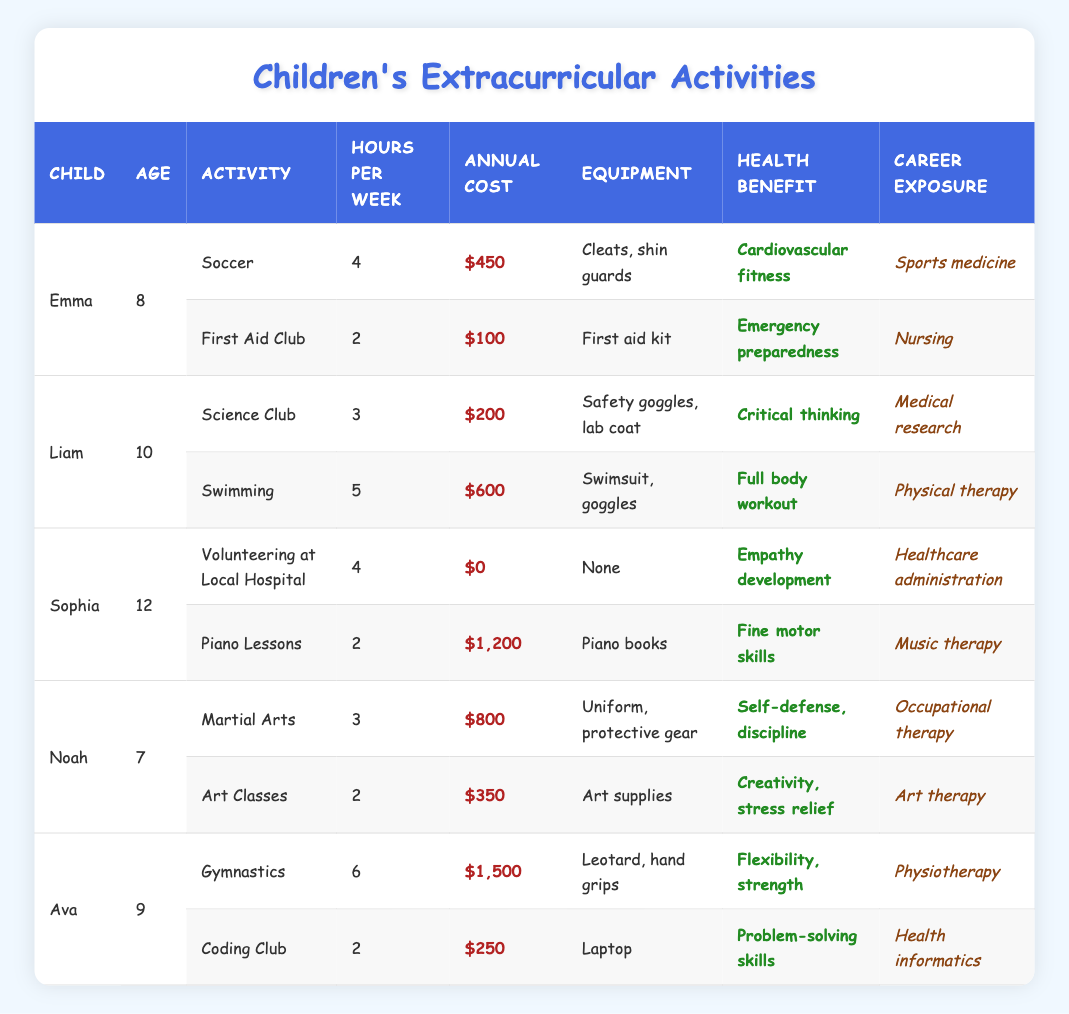What is the annual cost for Liam's swimming activity? In the table, Liam's swimming activity is listed under the row with the Activity as "Swimming." The corresponding Annual Cost is represented in the table as $600.
Answer: $600 How many hours per week does Emma devote to her extracurricular activities? Emma has two activities: "Soccer" which takes 4 hours per week and "First Aid Club" which takes 2 hours per week. Adding those together gives 4 + 2 = 6 hours per week.
Answer: 6 hours Which child participates in the highest cost activity? The activities are listed with their respective annual costs. Comparing them, Ava's "Gymnastics" activity has the highest cost at $1,500.
Answer: Ava How many children are involved in healthcare-related activities? The activities that relate to healthcare are "First Aid Club" (Emma), "Volunteering at Local Hospital" (Sophia), and "Nursing" from the First Aid Club. Thus, 3 children are participating in healthcare-related activities.
Answer: 3 What is the total annual cost for all activities of Noah? Noah has two activities: "Martial Arts" costing $800 and "Art Classes" costing $350. Adding these two costs gives $800 + $350 = $1,150 as the total annual cost.
Answer: $1,150 Is there any activity in the table that has no annual cost? Yes, Sophia's "Volunteering at Local Hospital" has an annual cost listed as $0. Hence, it indicates that this activity incurs no cost.
Answer: Yes What is the combined number of hours per week for all activities related to physical therapy careers? Liam's swimming (5 hours) and Ava's gymnastics (6 hours) are related to physical therapy careers. Adding these hours gives 5 + 6 = 11 hours per week for physical therapy-related activities.
Answer: 11 hours Which child has the lowest annual cost for their activities? Looking at the annual costs, Emma's "First Aid Club" has the lowest cost at $100. This is lower than any other costs in the table.
Answer: Emma What is the average annual cost of all activities listed in the table? The total annual cost sums up to $450 (Emma's soccer) + $100 (First Aid Club) + $200 (Liam's Science Club) + $600 (Swimming) + $0 (Sophia's volunteering) + $1,200 (Piano Lessons) + $800 (Noah's Martial Arts) + $350 (Art Classes) + $1,500 (Ava's Gymnastics) + $250 (Coding Club) = $5,150. There are 10 activities, so the average is $5,150 / 10 = $515.
Answer: $515 